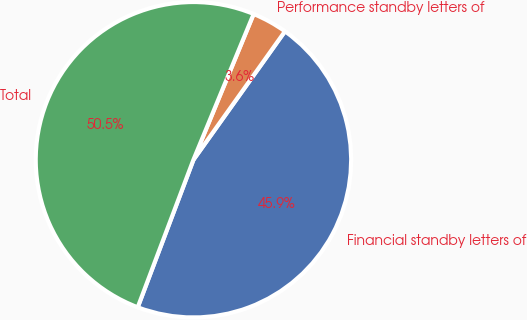Convert chart. <chart><loc_0><loc_0><loc_500><loc_500><pie_chart><fcel>Financial standby letters of<fcel>Performance standby letters of<fcel>Total<nl><fcel>45.89%<fcel>3.62%<fcel>50.48%<nl></chart> 